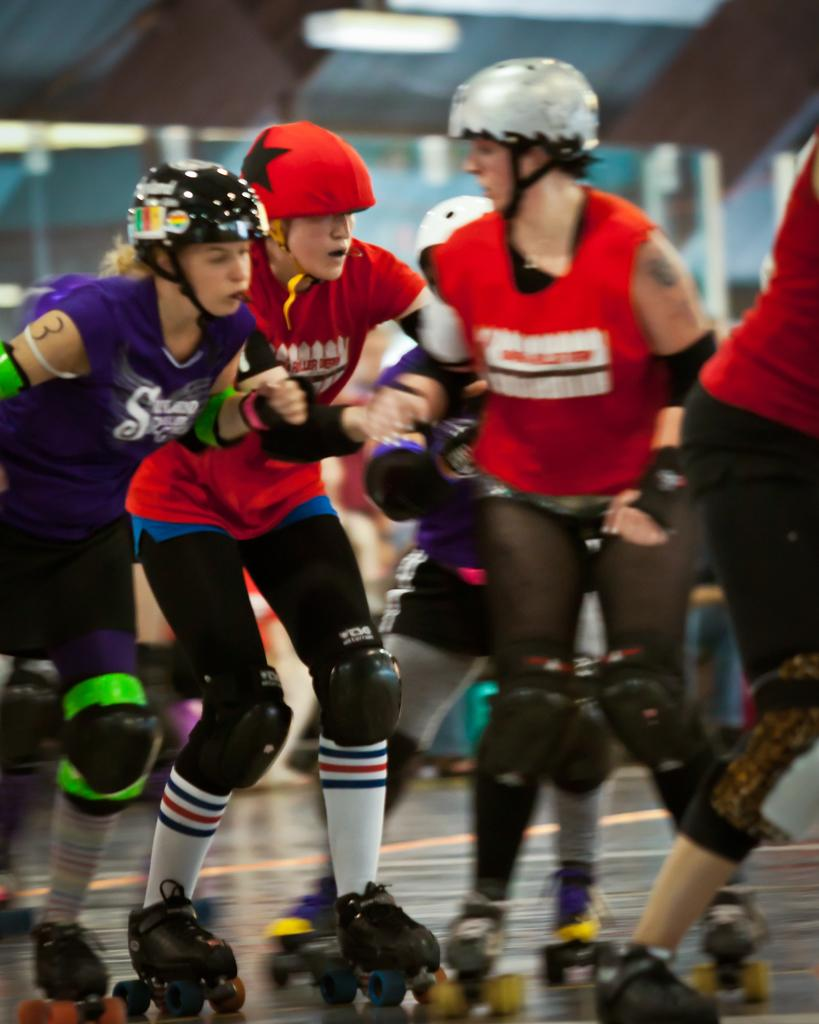How many people are in the image? There is a group of people in the image. What are the people wearing on their heads? The people are wearing helmets. What type of footwear are the people wearing? The people are wearing skates. What can be seen hanging from the roof in the image? There are lights hanging from the roof in the image. What type of frame is holding the statement in the image? There is no frame or statement present in the image; it features a group of people wearing helmets and skates, with lights hanging from the roof. 